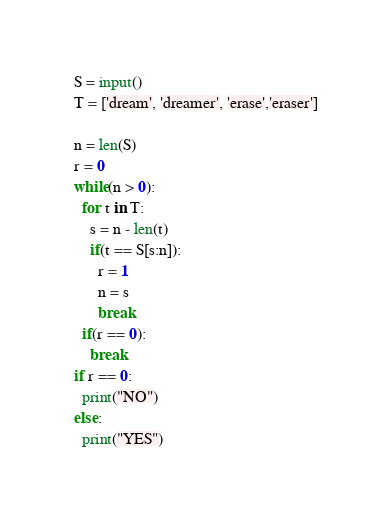<code> <loc_0><loc_0><loc_500><loc_500><_Python_>S = input()
T = ['dream', 'dreamer', 'erase','eraser']

n = len(S)
r = 0
while(n > 0):
  for t in T:
    s = n - len(t)
    if(t == S[s:n]):
      r = 1
      n = s
      break
  if(r == 0):
    break
if r == 0:
  print("NO")
else:
  print("YES")</code> 